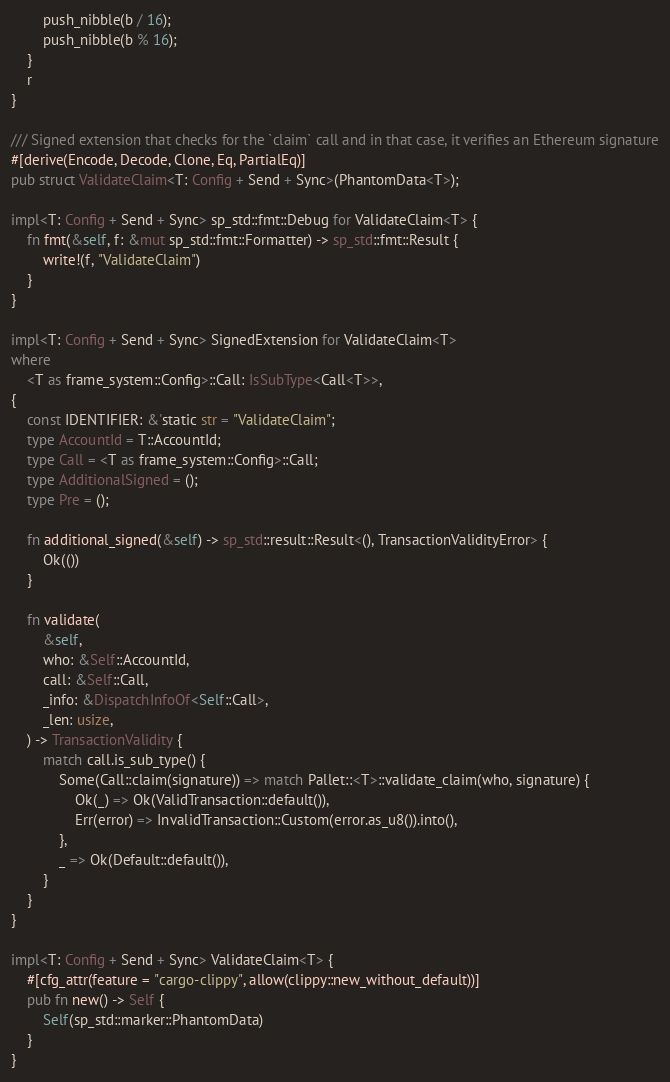Convert code to text. <code><loc_0><loc_0><loc_500><loc_500><_Rust_>		push_nibble(b / 16);
		push_nibble(b % 16);
	}
	r
}

/// Signed extension that checks for the `claim` call and in that case, it verifies an Ethereum signature
#[derive(Encode, Decode, Clone, Eq, PartialEq)]
pub struct ValidateClaim<T: Config + Send + Sync>(PhantomData<T>);

impl<T: Config + Send + Sync> sp_std::fmt::Debug for ValidateClaim<T> {
	fn fmt(&self, f: &mut sp_std::fmt::Formatter) -> sp_std::fmt::Result {
		write!(f, "ValidateClaim")
	}
}

impl<T: Config + Send + Sync> SignedExtension for ValidateClaim<T>
where
	<T as frame_system::Config>::Call: IsSubType<Call<T>>,
{
	const IDENTIFIER: &'static str = "ValidateClaim";
	type AccountId = T::AccountId;
	type Call = <T as frame_system::Config>::Call;
	type AdditionalSigned = ();
	type Pre = ();

	fn additional_signed(&self) -> sp_std::result::Result<(), TransactionValidityError> {
		Ok(())
	}

	fn validate(
		&self,
		who: &Self::AccountId,
		call: &Self::Call,
		_info: &DispatchInfoOf<Self::Call>,
		_len: usize,
	) -> TransactionValidity {
		match call.is_sub_type() {
			Some(Call::claim(signature)) => match Pallet::<T>::validate_claim(who, signature) {
				Ok(_) => Ok(ValidTransaction::default()),
				Err(error) => InvalidTransaction::Custom(error.as_u8()).into(),
			},
			_ => Ok(Default::default()),
		}
	}
}

impl<T: Config + Send + Sync> ValidateClaim<T> {
	#[cfg_attr(feature = "cargo-clippy", allow(clippy::new_without_default))]
	pub fn new() -> Self {
		Self(sp_std::marker::PhantomData)
	}
}
</code> 